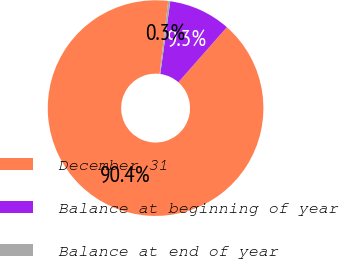Convert chart to OTSL. <chart><loc_0><loc_0><loc_500><loc_500><pie_chart><fcel>December 31<fcel>Balance at beginning of year<fcel>Balance at end of year<nl><fcel>90.37%<fcel>9.32%<fcel>0.31%<nl></chart> 